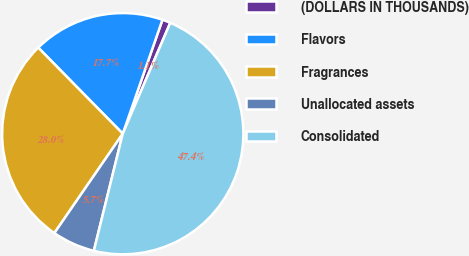<chart> <loc_0><loc_0><loc_500><loc_500><pie_chart><fcel>(DOLLARS IN THOUSANDS)<fcel>Flavors<fcel>Fragrances<fcel>Unallocated assets<fcel>Consolidated<nl><fcel>1.11%<fcel>17.69%<fcel>28.05%<fcel>5.74%<fcel>47.41%<nl></chart> 